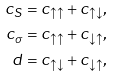<formula> <loc_0><loc_0><loc_500><loc_500>c _ { S } & = c _ { \uparrow \uparrow } + c _ { \uparrow \downarrow } , \\ c _ { \sigma } & = c _ { \uparrow \uparrow } + c _ { \downarrow \uparrow } , \\ d & = c _ { \uparrow \downarrow } + c _ { \downarrow \uparrow } ,</formula> 